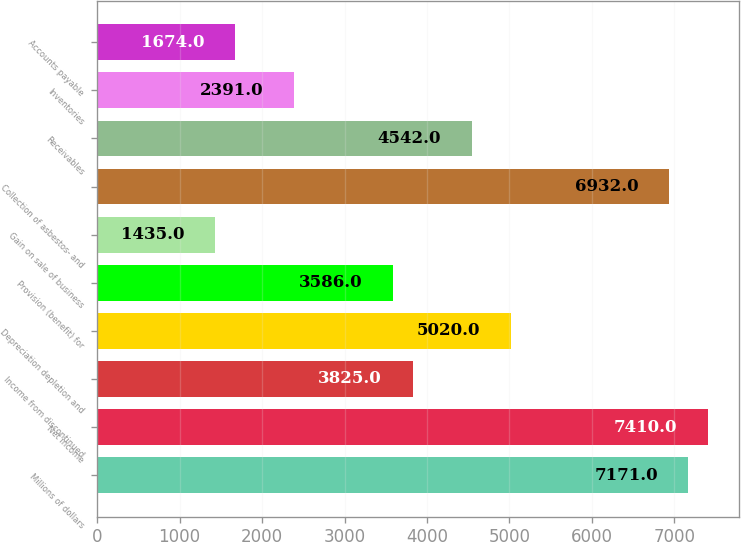Convert chart to OTSL. <chart><loc_0><loc_0><loc_500><loc_500><bar_chart><fcel>Millions of dollars<fcel>Net income<fcel>Income from discontinued<fcel>Depreciation depletion and<fcel>Provision (benefit) for<fcel>Gain on sale of business<fcel>Collection of asbestos- and<fcel>Receivables<fcel>Inventories<fcel>Accounts payable<nl><fcel>7171<fcel>7410<fcel>3825<fcel>5020<fcel>3586<fcel>1435<fcel>6932<fcel>4542<fcel>2391<fcel>1674<nl></chart> 